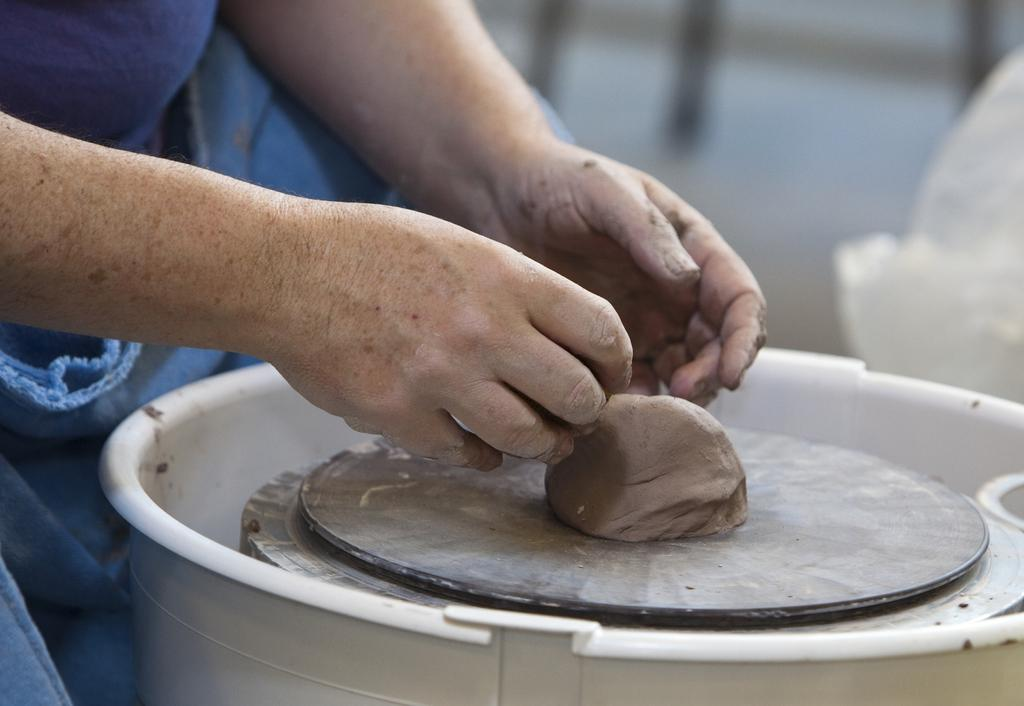What is being worked on in the image? There is mud placed on a pottery wheel in the image. Can you describe the person in the image? There is a person on the left side of the image. What type of pollution can be seen in the image? There is no pollution visible in the image; it features a person working with mud on a pottery wheel. Can you provide a suggestion for improving the pottery-making process in the image? The image does not provide enough information to suggest improvements to the pottery-making process. 